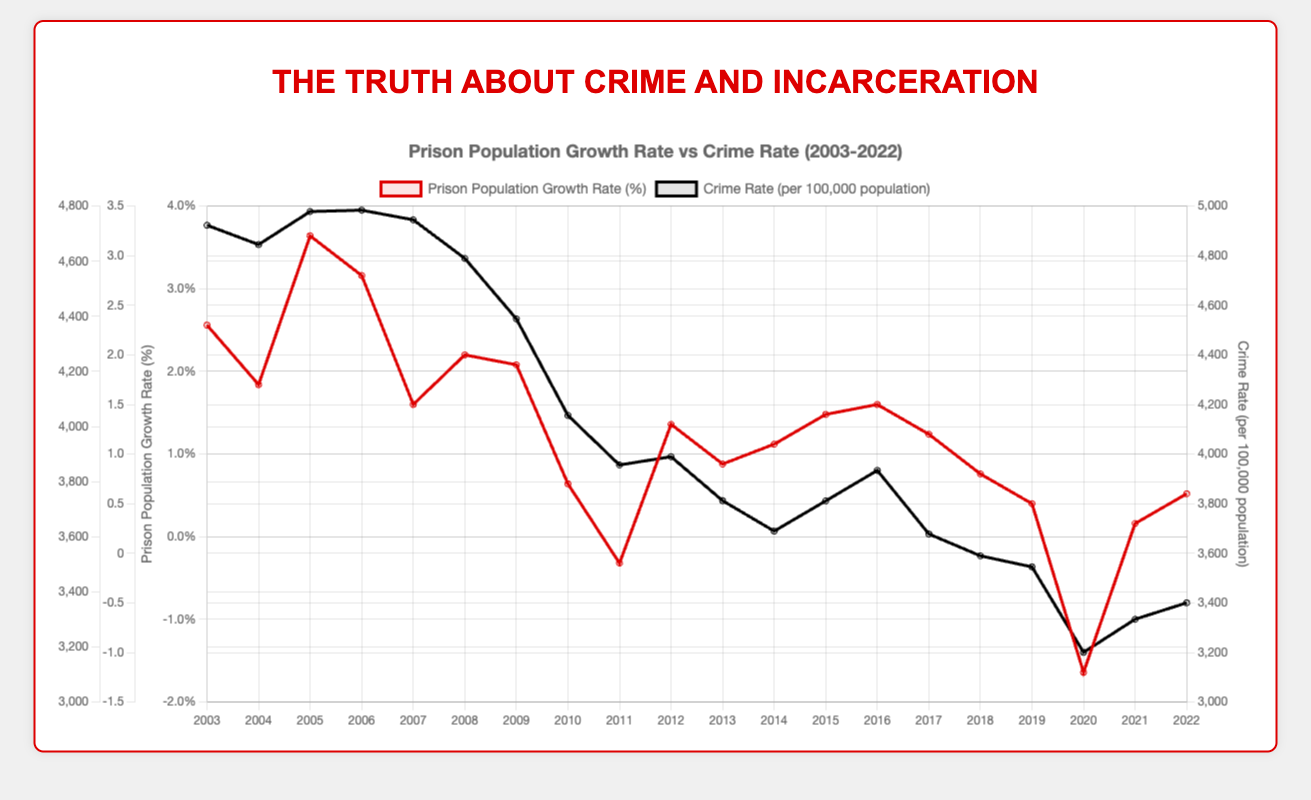Which year had the highest prison population growth rate? From the plot, the year 2005 shows the highest prison population growth rate where the curve reaches its peak around 3.2%.
Answer: 2005 How does the crime rate in 2020 compare with the prison population growth rate in the same year? In 2020, the prison population growth rate dipped to -1.2% and the crime rate was approximately 3180.6 per 100,000 population. Visually, the crime rate line is lower compared to other years, and the prison population growth rate line drops significantly below zero.
Answer: Crime rate was 3180.6 with a prison population growth rate of -1.2% Compare the trend of crime rate and prison population growth rate between 2003 and 2008. From 2003 to 2008, the crime rate shows a declining trend from around 4730.5 to 4610.1 per 100,000 population. The prison population growth rate, however, fluctuates, peaking in 2005 at 3.2% and then generally falling to 2.0% in 2008.
Answer: Crime rate decreased, prison population growth rate fluctuated Which year had a negative prison population growth rate and how does the crime rate in that year compare to other years? The year 2011 and 2020 had negative prison population growth rates at -0.1% and -1.2%, respectively. In 2011, the crime rate was approximately 3860.6, which is relatively lower than earlier years. In 2020, the crime rate was about 3180.6, one of the lowest in the entire plot.
Answer: 2011 and 2020, crime rate was relatively lower What is the difference in crime rate between 2003 and 2022? The crime rate in 2003 was approximately 4730.5 per 100,000 population, and in 2022 it was around 3360.3. The difference can be calculated as 4730.5 - 3360.3 = 1370.2 per 100,000 population.
Answer: 1370.2 What trends can you observe about the prison population growth rate and crime rate from 2015 to 2020? From 2015 to 2020, the crime rate shows a decreasing trend from around 3730.2 down to 3180.6. The prison population growth rate also follows a downward trend starting from 1.4% in 2015 and dipping to -1.2% in 2020.
Answer: Both crime rate and prison population growth rate decreased Which dataset, prison population growth rate or crime rate, shows a more dramatic fluctuation over the two decades? Visually, the prison population growth rate curve fluctuates more significantly, showing peaks and troughs in multiple years especially around 2005, 2006, and 2020. The crime rate line, while generally decreasing, shows less dramatic changes over the same period.
Answer: Prison population growth rate When did the prison population growth rate drop below 1% for the first time, and what was the crime rate that year? The prison population growth rate dropped below 1% for the first time in 2010, reaching 0.7%. The crime rate that year was approximately 4040.3 per 100,000 population.
Answer: 2010, crime rate was 4040.3 What can be inferred about the relationship between crime rate and prison population growth rate over these two decades? Over the two decades, the crime rate shows a general downward trend while the prison population growth rate fluctuates. Although there isn't a clear one-to-one correlation, periods of reduced crime like between 2009 and 2015 generally align with lower prison population growth rates.
Answer: Decreasing crime rate, fluctuating prison population growth rate 